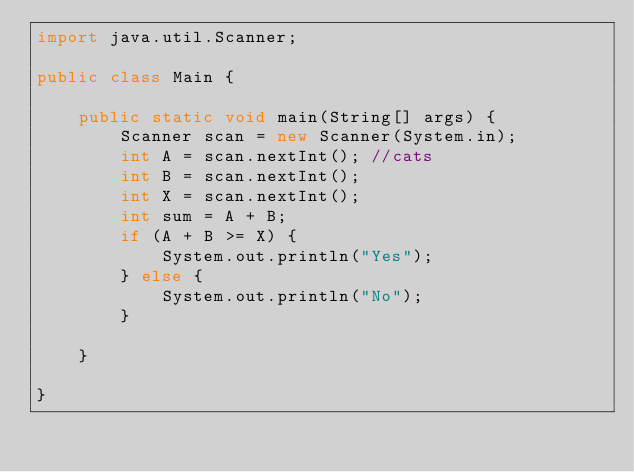<code> <loc_0><loc_0><loc_500><loc_500><_Java_>import java.util.Scanner;

public class Main {

	public static void main(String[] args) {
		Scanner scan = new Scanner(System.in);
		int A = scan.nextInt(); //cats
		int B = scan.nextInt();
		int X = scan.nextInt();
		int sum = A + B;
		if (A + B >= X) {
			System.out.println("Yes");
		} else {
			System.out.println("No");
		}

	}

}
</code> 